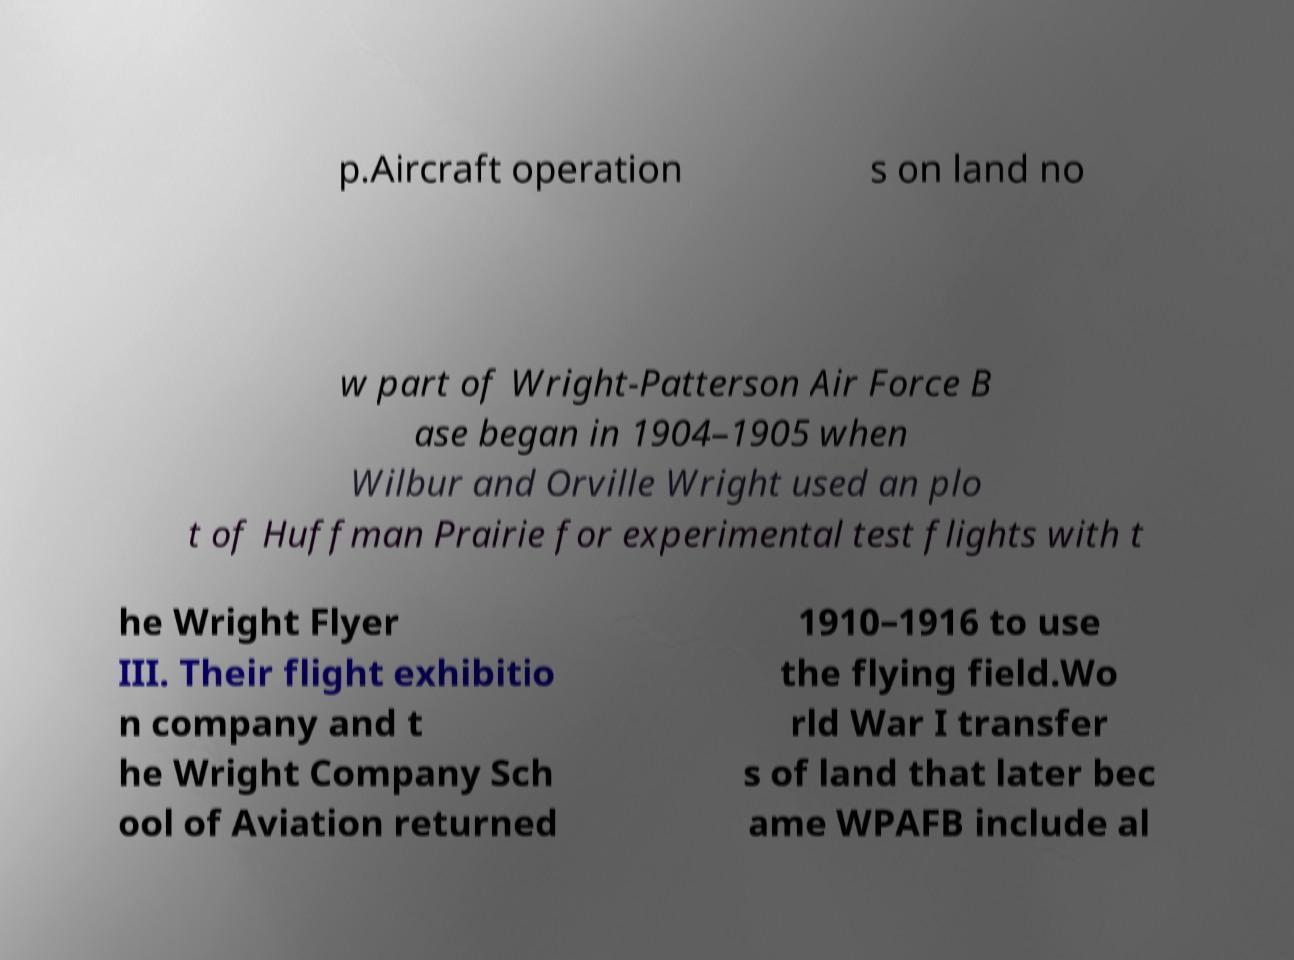What messages or text are displayed in this image? I need them in a readable, typed format. p.Aircraft operation s on land no w part of Wright-Patterson Air Force B ase began in 1904–1905 when Wilbur and Orville Wright used an plo t of Huffman Prairie for experimental test flights with t he Wright Flyer III. Their flight exhibitio n company and t he Wright Company Sch ool of Aviation returned 1910–1916 to use the flying field.Wo rld War I transfer s of land that later bec ame WPAFB include al 